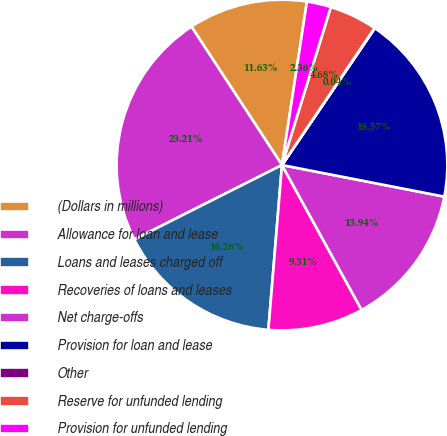Convert chart to OTSL. <chart><loc_0><loc_0><loc_500><loc_500><pie_chart><fcel>(Dollars in millions)<fcel>Allowance for loan and lease<fcel>Loans and leases charged off<fcel>Recoveries of loans and leases<fcel>Net charge-offs<fcel>Provision for loan and lease<fcel>Other<fcel>Reserve for unfunded lending<fcel>Provision for unfunded lending<nl><fcel>11.63%<fcel>23.21%<fcel>16.26%<fcel>9.31%<fcel>13.94%<fcel>18.57%<fcel>0.04%<fcel>4.68%<fcel>2.36%<nl></chart> 